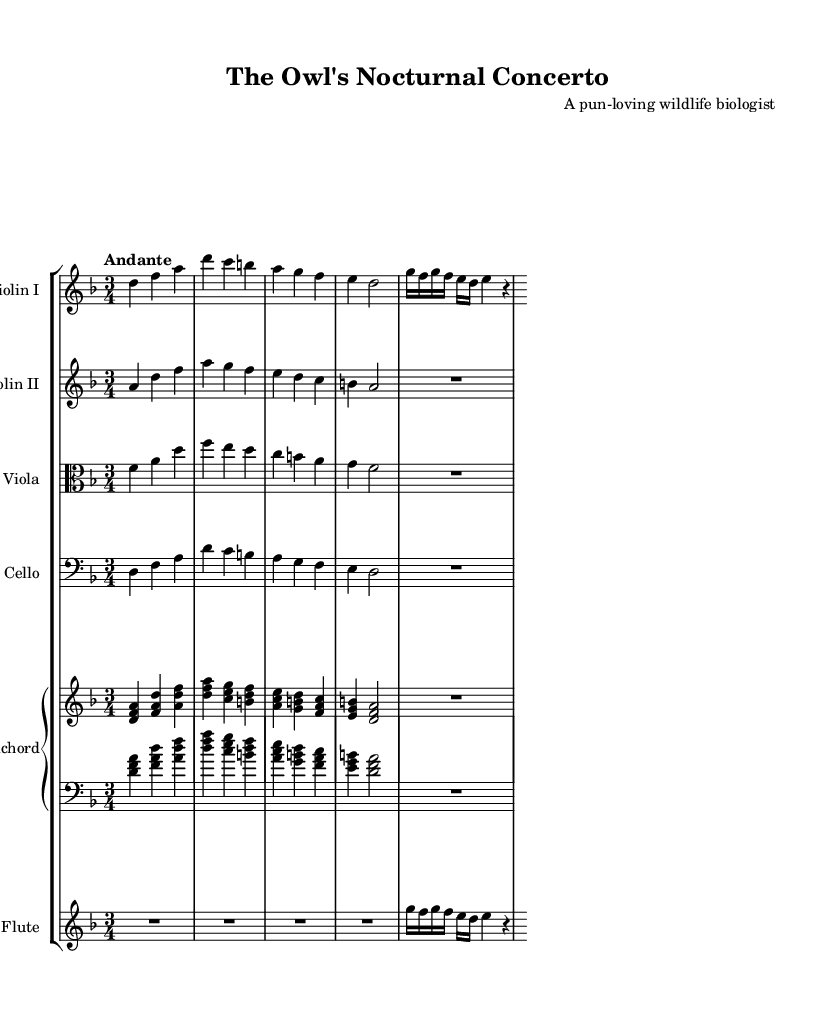What is the key signature of this music? The key signature is indicated at the beginning of the score. It shows two flats, which correspond to D minor.
Answer: D minor What is the time signature of this music? The time signature is found next to the key signature at the beginning of the score. It is 3/4, indicating three beats per measure.
Answer: 3/4 What is the tempo marking of this music? The tempo marking is provided above the score, indicating the speed of the piece. It states "Andante," which suggests a moderately slow tempo.
Answer: Andante Which instruments are included in this concerto? The instruments are listed in the score, revealing a group of strings and a flute. They include Violin I, Violin II, Viola, Cello, Harpsichord, and Flute.
Answer: Violin I, Violin II, Viola, Cello, Harpsichord, Flute How many measures are in the piece presented? By counting each distinct set of notes or rests separated by bar lines, we find there are a total of 10 measures throughout the score.
Answer: 10 measures What is the primary motif of the flute section? By examining the flute part, it primarily features rapid melodic movement, specifically the rising and falling figures, suggesting bird calls.
Answer: Bird calls 